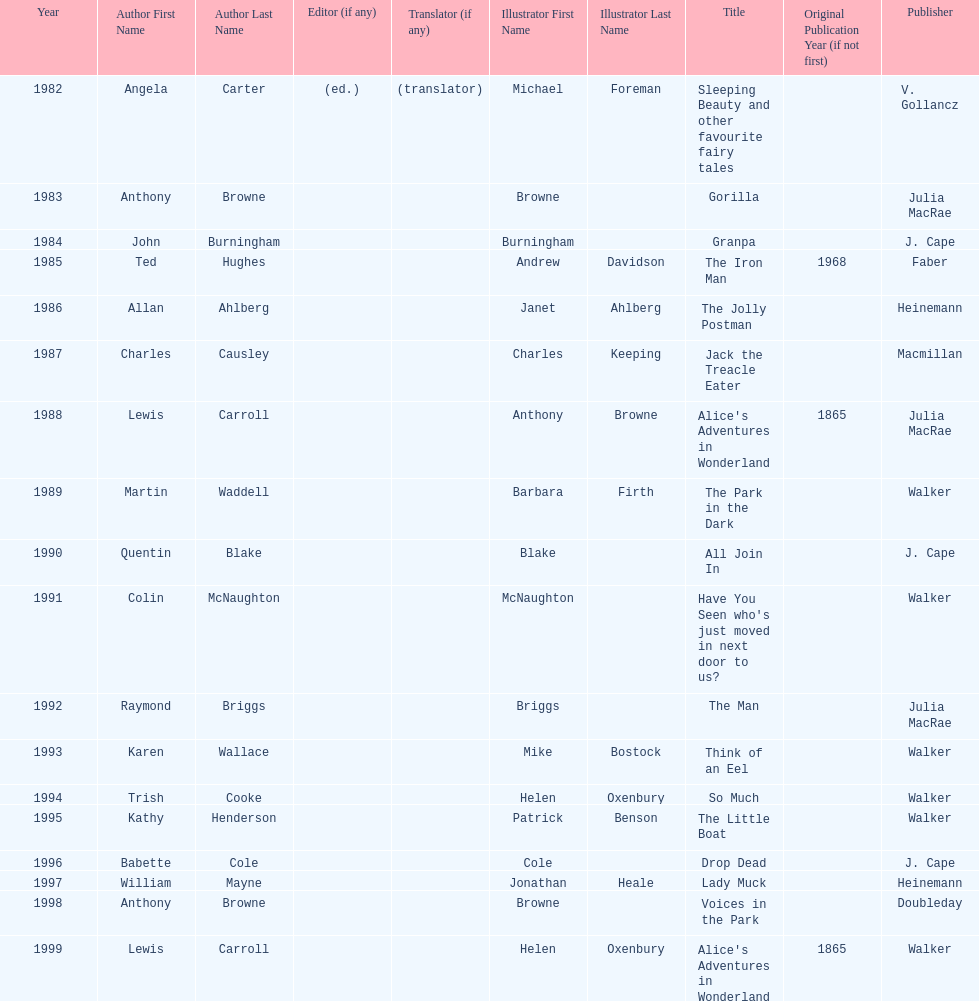How many titles did walker publish? 6. 